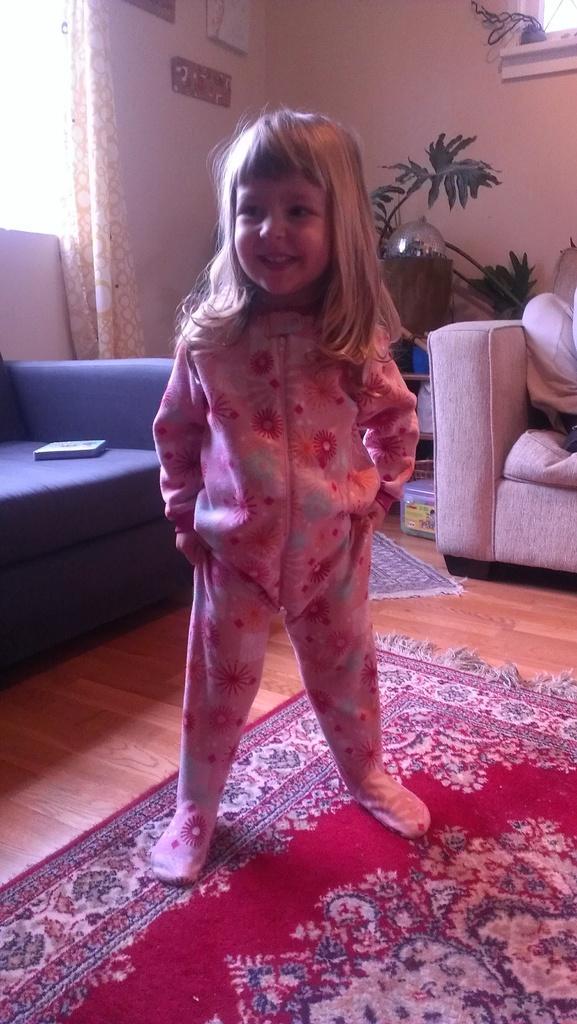Can you describe this image briefly? In this picture we can see a girl smiling. We can see an object on a sofa on the left side. We can see another sofa. There is a box, plant, boards on the wall and a black object in the background. We can see a carpet on the floor. 